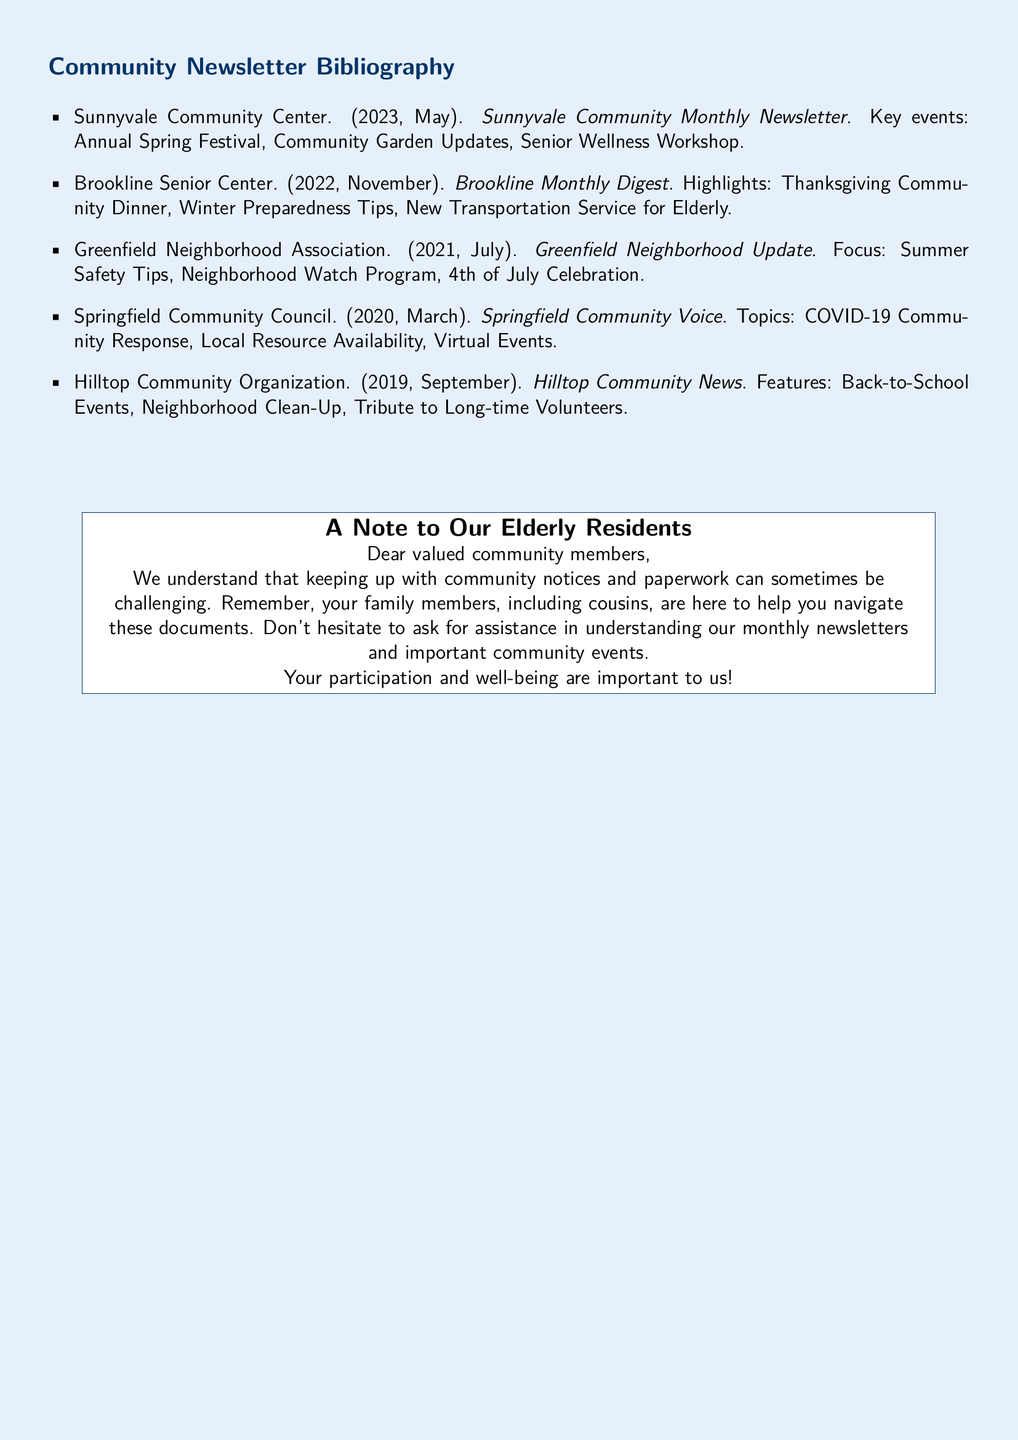What is the title of the May 2023 newsletter? The title of the May 2023 newsletter is mentioned as "Sunnyvale Community Monthly Newsletter".
Answer: Sunnyvale Community Monthly Newsletter What is a key event highlighted in the November 2022 newsletter? The November 2022 newsletter lists "Thanksgiving Community Dinner" as a key event.
Answer: Thanksgiving Community Dinner Which organization published the July 2021 newsletter? The July 2021 newsletter was published by the "Greenfield Neighborhood Association".
Answer: Greenfield Neighborhood Association What specific topic was covered in the March 2020 newsletter? The March 2020 newsletter focused on "COVID-19 Community Response".
Answer: COVID-19 Community Response How many years of newsletters are included in this bibliography? The document mentions that it includes newsletters from the last five years.
Answer: Five years What event is mentioned in the September 2019 newsletter? The September 2019 newsletter features "Back-to-School Events".
Answer: Back-to-School Events Which community center offered a Senior Wellness Workshop in May 2023? The Sunnyvale Community Center offered a Senior Wellness Workshop in May 2023.
Answer: Sunnyvale Community Center What is the purpose of the note to elderly residents? The note emphasizes the importance of understanding community notices and offers assistance with paperwork.
Answer: Understanding community notices and offers assistance Which month does the Hilltop Community News belong to? The Hilltop Community News is from September.
Answer: September 